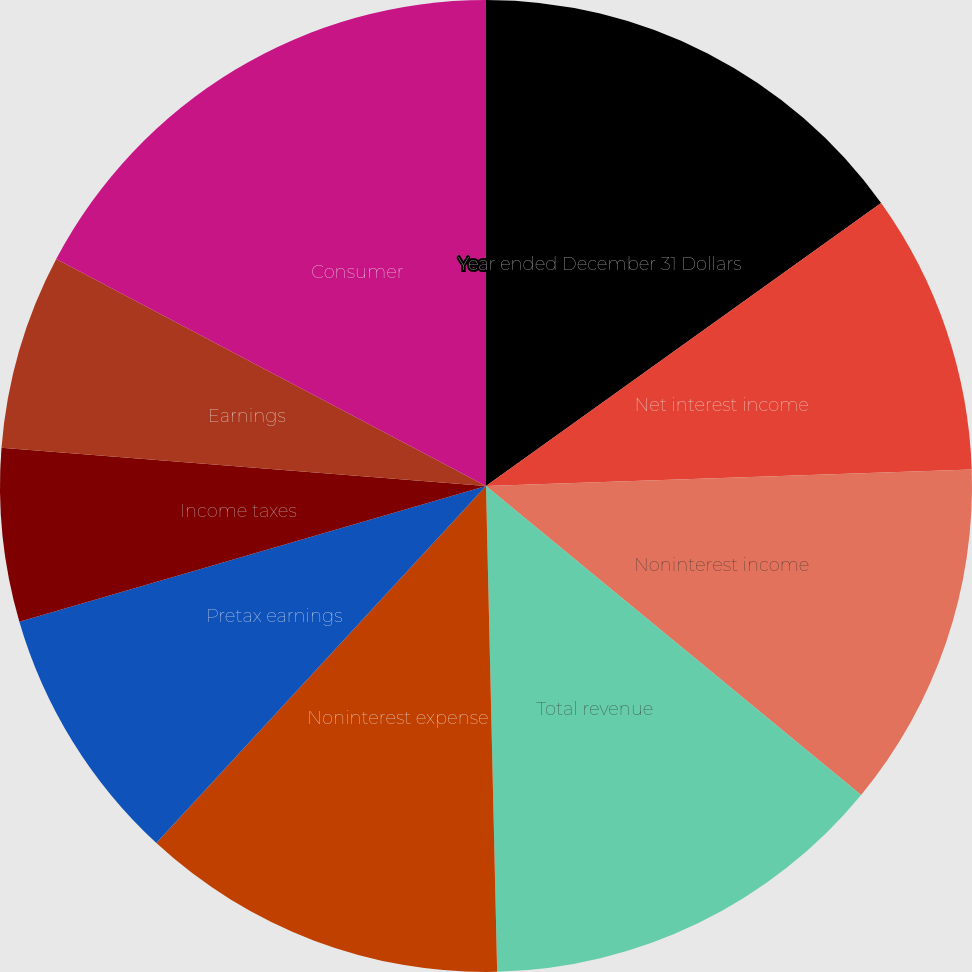<chart> <loc_0><loc_0><loc_500><loc_500><pie_chart><fcel>Year ended December 31 Dollars<fcel>Net interest income<fcel>Noninterest income<fcel>Total revenue<fcel>Provision for credit losses<fcel>Noninterest expense<fcel>Pretax earnings<fcel>Income taxes<fcel>Earnings<fcel>Consumer<nl><fcel>15.11%<fcel>9.35%<fcel>11.51%<fcel>13.67%<fcel>0.0%<fcel>12.23%<fcel>8.63%<fcel>5.76%<fcel>6.48%<fcel>17.27%<nl></chart> 